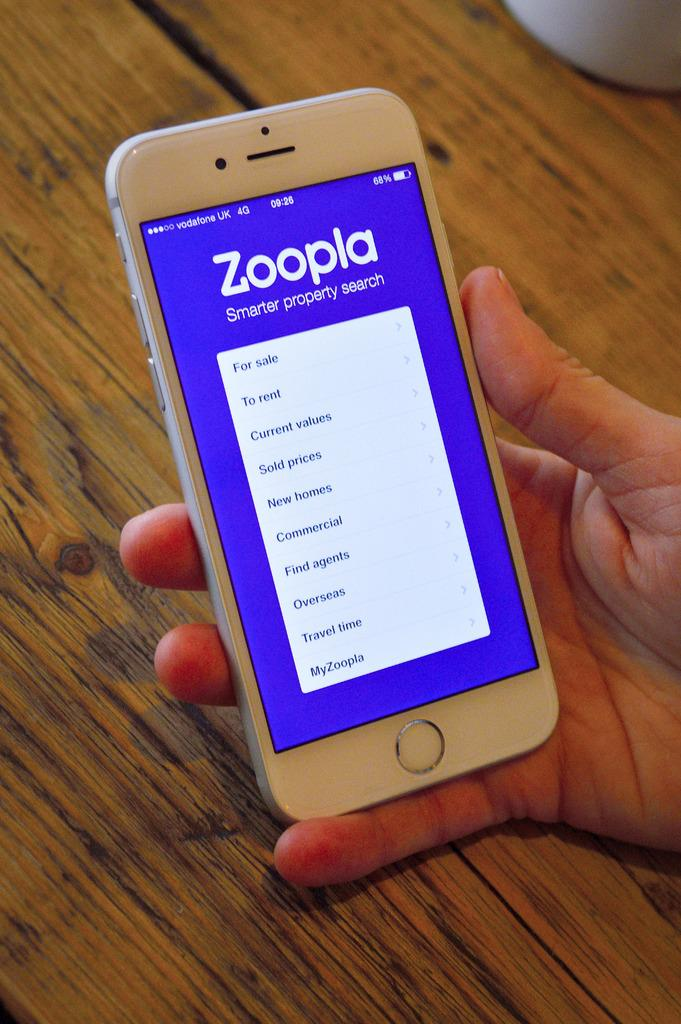<image>
Describe the image concisely. A hand holding a smartphone showing a property search app 